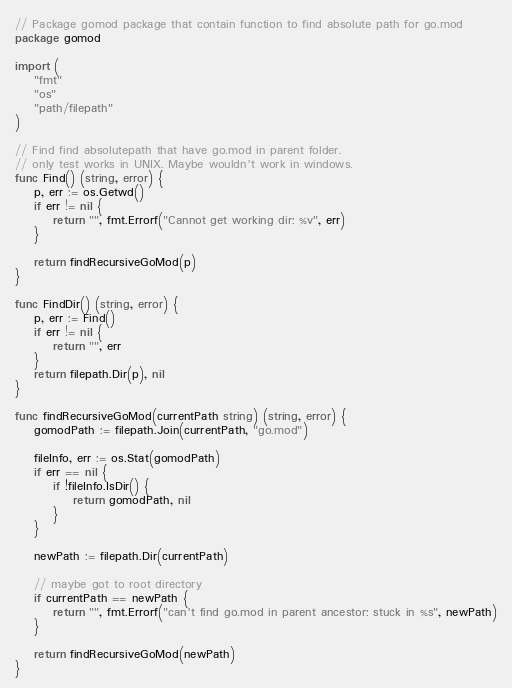<code> <loc_0><loc_0><loc_500><loc_500><_Go_>// Package gomod package that contain function to find absolute path for go.mod
package gomod

import (
	"fmt"
	"os"
	"path/filepath"
)

// Find find absolutepath that have go.mod in parent folder.
// only test works in UNIX. Maybe wouldn't work in windows.
func Find() (string, error) {
	p, err := os.Getwd()
	if err != nil {
		return "", fmt.Errorf("Cannot get working dir: %v", err)
	}

	return findRecursiveGoMod(p)
}

func FindDir() (string, error) {
	p, err := Find()
	if err != nil {
		return "", err
	}
	return filepath.Dir(p), nil
}

func findRecursiveGoMod(currentPath string) (string, error) {
	gomodPath := filepath.Join(currentPath, "go.mod")

	fileInfo, err := os.Stat(gomodPath)
	if err == nil {
		if !fileInfo.IsDir() {
			return gomodPath, nil
		}
	}

	newPath := filepath.Dir(currentPath)

	// maybe got to root directory
	if currentPath == newPath {
		return "", fmt.Errorf("can't find go.mod in parent ancestor: stuck in %s", newPath)
	}

	return findRecursiveGoMod(newPath)
}
</code> 